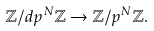<formula> <loc_0><loc_0><loc_500><loc_500>\mathbb { Z } / d p ^ { N } \mathbb { Z } \rightarrow \mathbb { Z } / p ^ { N } \mathbb { Z } .</formula> 